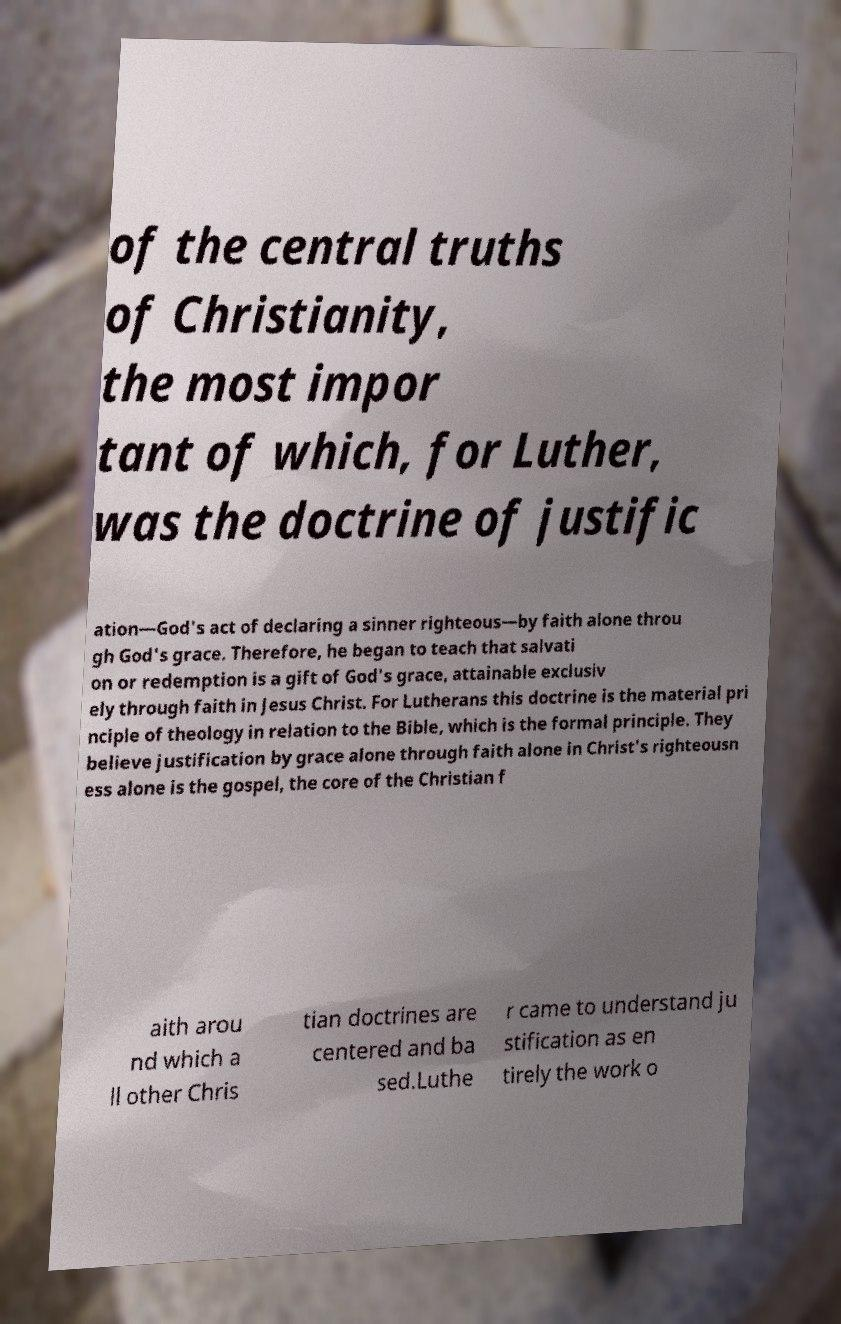Can you accurately transcribe the text from the provided image for me? of the central truths of Christianity, the most impor tant of which, for Luther, was the doctrine of justific ation—God's act of declaring a sinner righteous—by faith alone throu gh God's grace. Therefore, he began to teach that salvati on or redemption is a gift of God's grace, attainable exclusiv ely through faith in Jesus Christ. For Lutherans this doctrine is the material pri nciple of theology in relation to the Bible, which is the formal principle. They believe justification by grace alone through faith alone in Christ's righteousn ess alone is the gospel, the core of the Christian f aith arou nd which a ll other Chris tian doctrines are centered and ba sed.Luthe r came to understand ju stification as en tirely the work o 